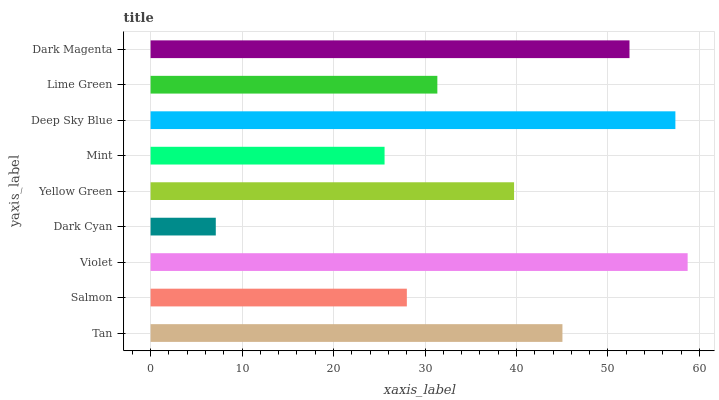Is Dark Cyan the minimum?
Answer yes or no. Yes. Is Violet the maximum?
Answer yes or no. Yes. Is Salmon the minimum?
Answer yes or no. No. Is Salmon the maximum?
Answer yes or no. No. Is Tan greater than Salmon?
Answer yes or no. Yes. Is Salmon less than Tan?
Answer yes or no. Yes. Is Salmon greater than Tan?
Answer yes or no. No. Is Tan less than Salmon?
Answer yes or no. No. Is Yellow Green the high median?
Answer yes or no. Yes. Is Yellow Green the low median?
Answer yes or no. Yes. Is Dark Cyan the high median?
Answer yes or no. No. Is Violet the low median?
Answer yes or no. No. 